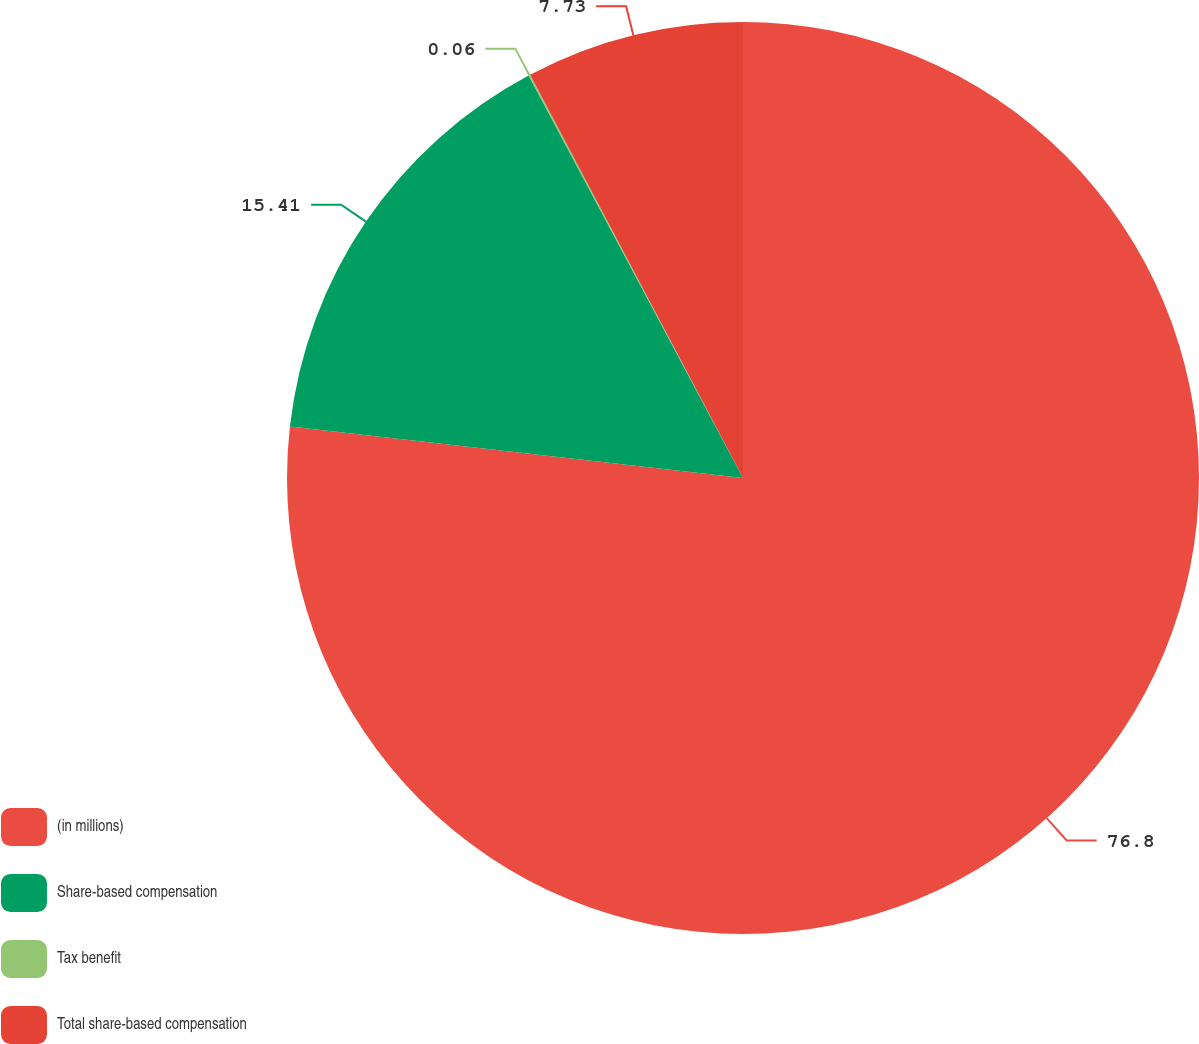Convert chart. <chart><loc_0><loc_0><loc_500><loc_500><pie_chart><fcel>(in millions)<fcel>Share-based compensation<fcel>Tax benefit<fcel>Total share-based compensation<nl><fcel>76.8%<fcel>15.41%<fcel>0.06%<fcel>7.73%<nl></chart> 